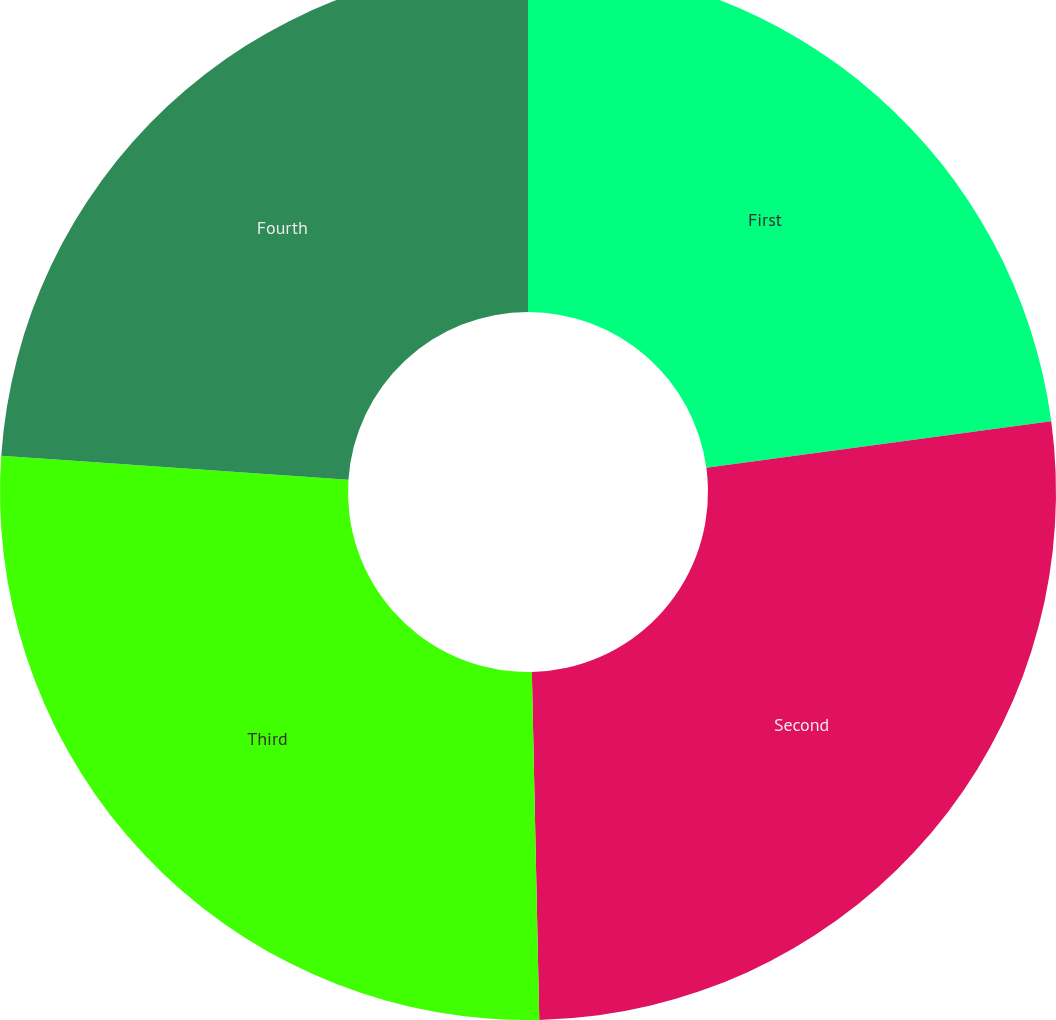Convert chart. <chart><loc_0><loc_0><loc_500><loc_500><pie_chart><fcel>First<fcel>Second<fcel>Third<fcel>Fourth<nl><fcel>22.86%<fcel>26.8%<fcel>26.43%<fcel>23.91%<nl></chart> 